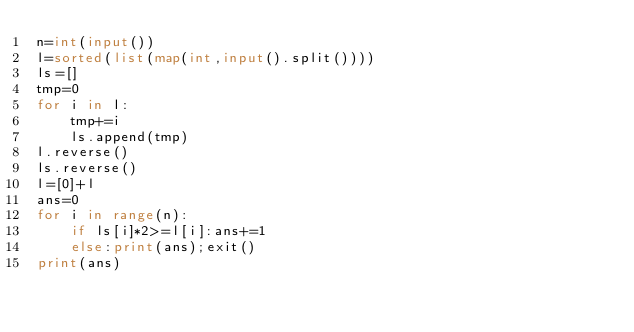<code> <loc_0><loc_0><loc_500><loc_500><_Python_>n=int(input())
l=sorted(list(map(int,input().split())))
ls=[]
tmp=0
for i in l:
    tmp+=i
    ls.append(tmp)
l.reverse()
ls.reverse()
l=[0]+l
ans=0
for i in range(n):
    if ls[i]*2>=l[i]:ans+=1
    else:print(ans);exit()
print(ans)</code> 